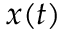Convert formula to latex. <formula><loc_0><loc_0><loc_500><loc_500>x ( t )</formula> 